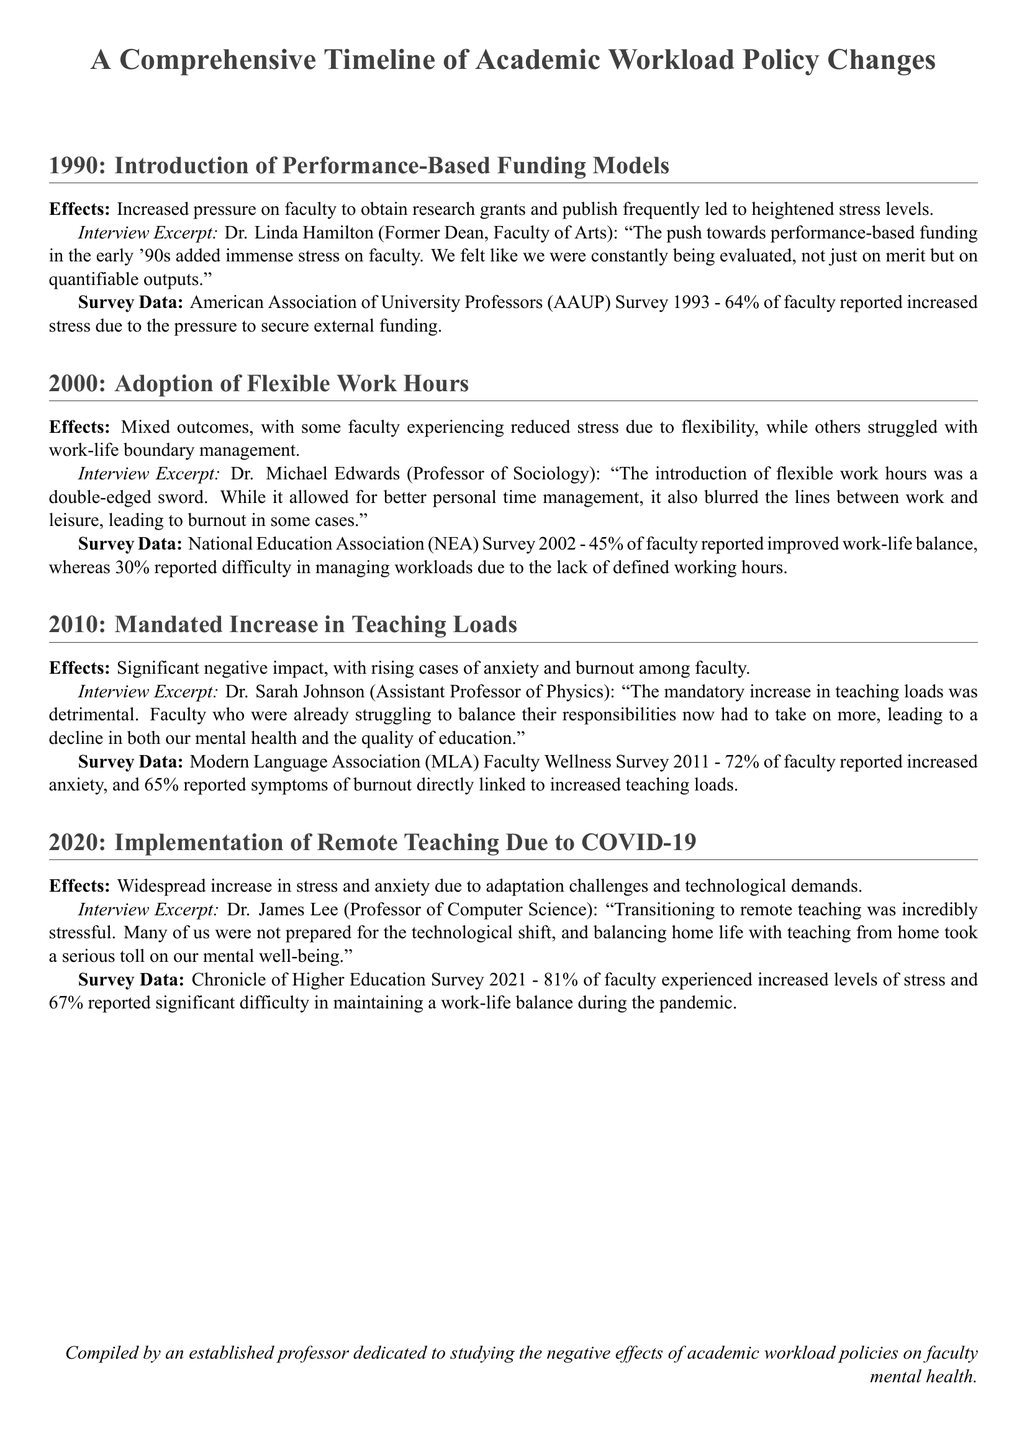What year did performance-based funding models get introduced? The document states that performance-based funding models were introduced in 1990.
Answer: 1990 What percentage of faculty reported increased stress due to performance-based funding in 1993? The document provides survey data showing that 64% of faculty reported increased stress from performance-based funding.
Answer: 64% Who is Dr. Sarah Johnson? Dr. Sarah Johnson is identified as an Assistant Professor of Physics in the document.
Answer: Assistant Professor of Physics What was a potential negative effect of flexible work hours according to Dr. Michael Edwards? The document mentions that flexible work hours led to blurred lines between work and leisure, causing burnout in some cases.
Answer: Burnout What percentage of faculty experienced increased levels of stress during the transition to remote teaching in 2021? The document states that 81% of faculty experienced increased levels of stress during remote teaching.
Answer: 81% What was a key theme from Dr. James Lee's interview regarding remote teaching? The document indicates that the transition was incredibly stressful and many were unprepared for the technological shift.
Answer: Stressful What survey documented a 72% increase in anxiety linked to increased teaching loads? The Modern Language Association (MLA) Faculty Wellness Survey 2011 documented this increase.
Answer: MLA Faculty Wellness Survey 2011 What was the percentage of faculty who reported difficulty in managing workloads due to flexible work hours in 2002? The document notes that 30% of faculty reported difficulty in managing workloads from flexible work hours.
Answer: 30% 